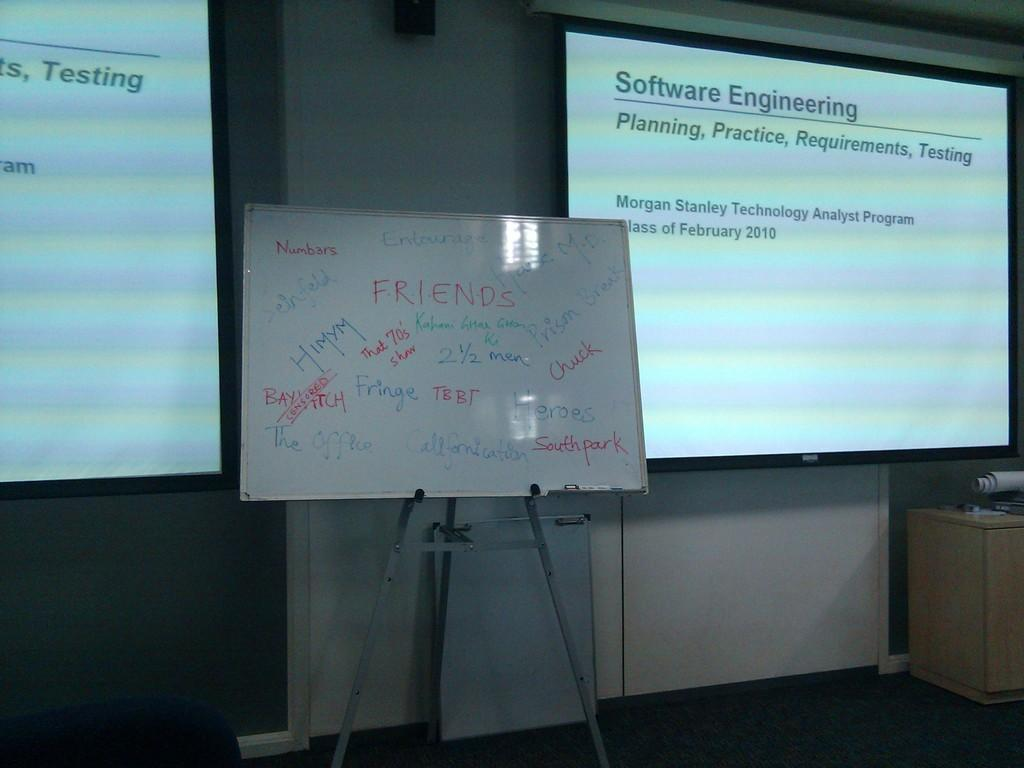Provide a one-sentence caption for the provided image. A classroom with Software Engineering slides at the front. 